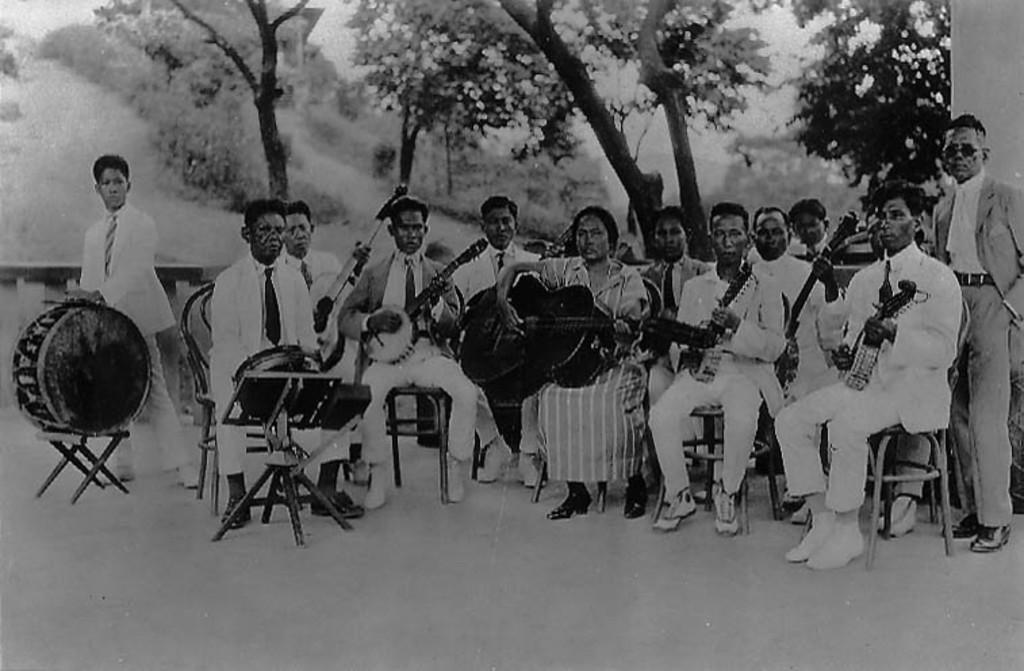What is the color scheme of the image? The image is black and white. What are the people in the image doing? The people are playing musical instruments. What can be seen in the background of the image? There are trees visible in the background of the image. Are the people in the image taking a bath together? No, there is no indication in the image that the people are taking a bath. The image shows a group of people playing musical instruments. 